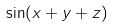Convert formula to latex. <formula><loc_0><loc_0><loc_500><loc_500>\sin ( x + y + z )</formula> 